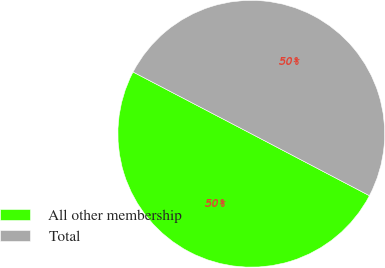Convert chart to OTSL. <chart><loc_0><loc_0><loc_500><loc_500><pie_chart><fcel>All other membership<fcel>Total<nl><fcel>49.98%<fcel>50.02%<nl></chart> 